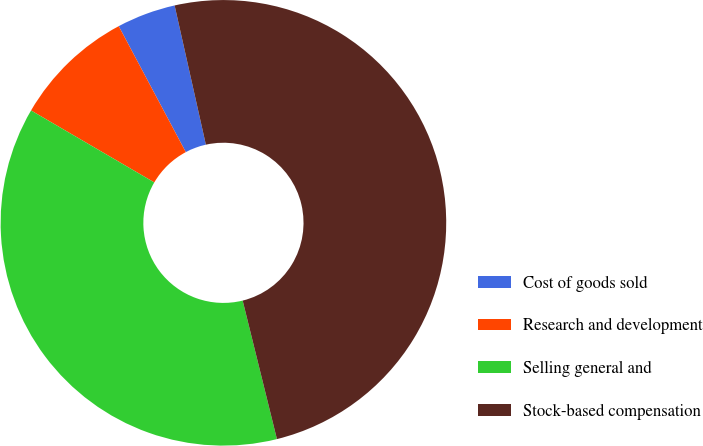Convert chart. <chart><loc_0><loc_0><loc_500><loc_500><pie_chart><fcel>Cost of goods sold<fcel>Research and development<fcel>Selling general and<fcel>Stock-based compensation<nl><fcel>4.27%<fcel>8.8%<fcel>37.27%<fcel>49.65%<nl></chart> 